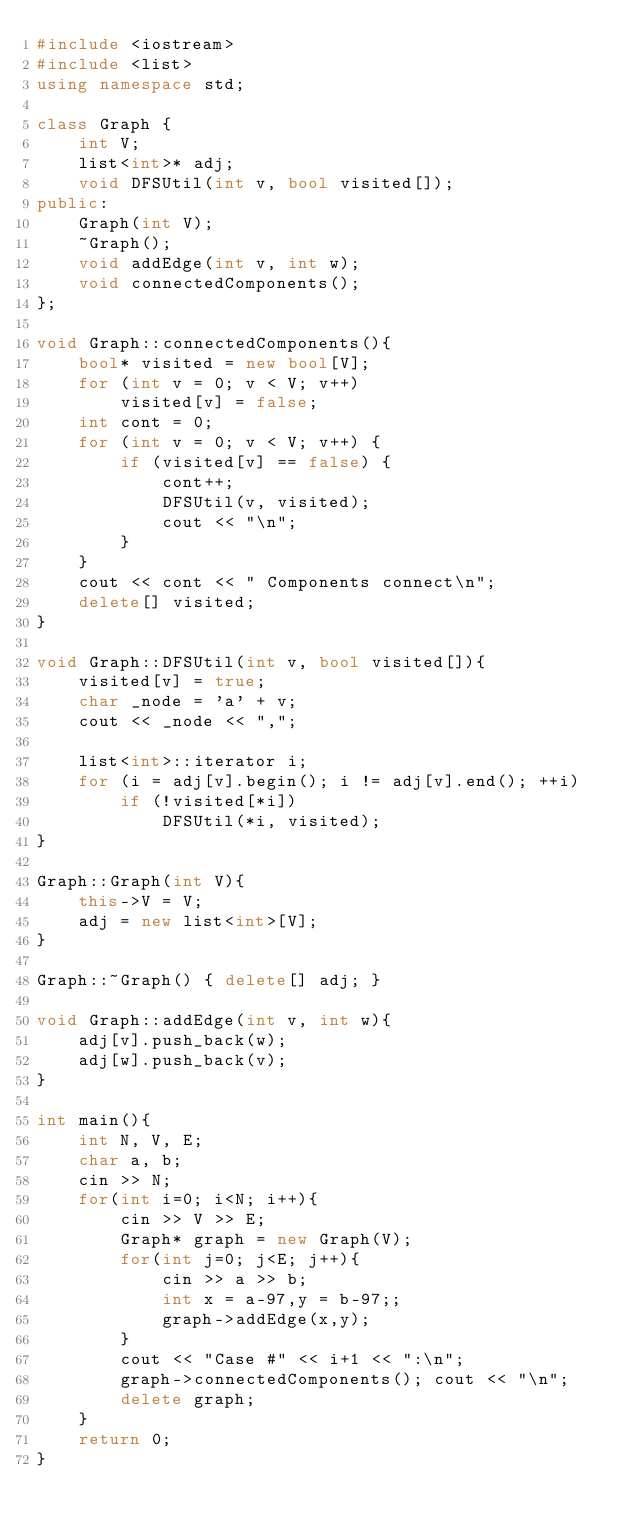Convert code to text. <code><loc_0><loc_0><loc_500><loc_500><_C++_>#include <iostream>
#include <list>
using namespace std;

class Graph {
    int V;
    list<int>* adj;
    void DFSUtil(int v, bool visited[]);
public:
    Graph(int V);
    ~Graph();
    void addEdge(int v, int w);
    void connectedComponents();
};

void Graph::connectedComponents(){
    bool* visited = new bool[V];
    for (int v = 0; v < V; v++)
        visited[v] = false;
    int cont = 0;
    for (int v = 0; v < V; v++) {
        if (visited[v] == false) {
            cont++;
            DFSUtil(v, visited);
            cout << "\n";
        }
    }
    cout << cont << " Components connect\n";
    delete[] visited;
}
 
void Graph::DFSUtil(int v, bool visited[]){
    visited[v] = true;
    char _node = 'a' + v;
    cout << _node << ",";
 
    list<int>::iterator i;
    for (i = adj[v].begin(); i != adj[v].end(); ++i)
        if (!visited[*i])
            DFSUtil(*i, visited);
}
 
Graph::Graph(int V){
    this->V = V;
    adj = new list<int>[V];
}
 
Graph::~Graph() { delete[] adj; }
 
void Graph::addEdge(int v, int w){
    adj[v].push_back(w);
    adj[w].push_back(v);
}

int main(){  
    int N, V, E;
    char a, b;
    cin >> N;
    for(int i=0; i<N; i++){
        cin >> V >> E;
        Graph* graph = new Graph(V);
        for(int j=0; j<E; j++){
            cin >> a >> b;
            int x = a-97,y = b-97;;
            graph->addEdge(x,y);
        }
        cout << "Case #" << i+1 << ":\n";
        graph->connectedComponents(); cout << "\n";
        delete graph;
    }
    return 0;
}</code> 